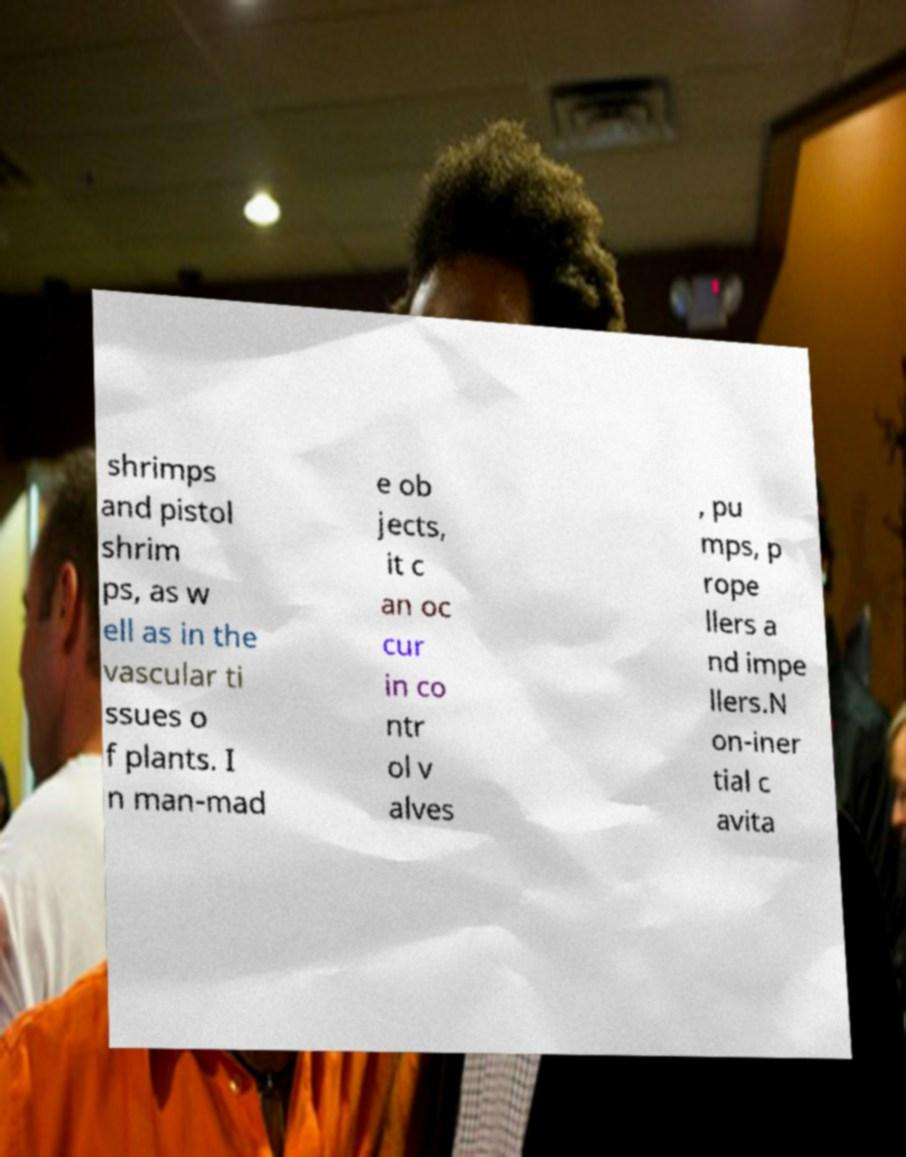What messages or text are displayed in this image? I need them in a readable, typed format. shrimps and pistol shrim ps, as w ell as in the vascular ti ssues o f plants. I n man-mad e ob jects, it c an oc cur in co ntr ol v alves , pu mps, p rope llers a nd impe llers.N on-iner tial c avita 